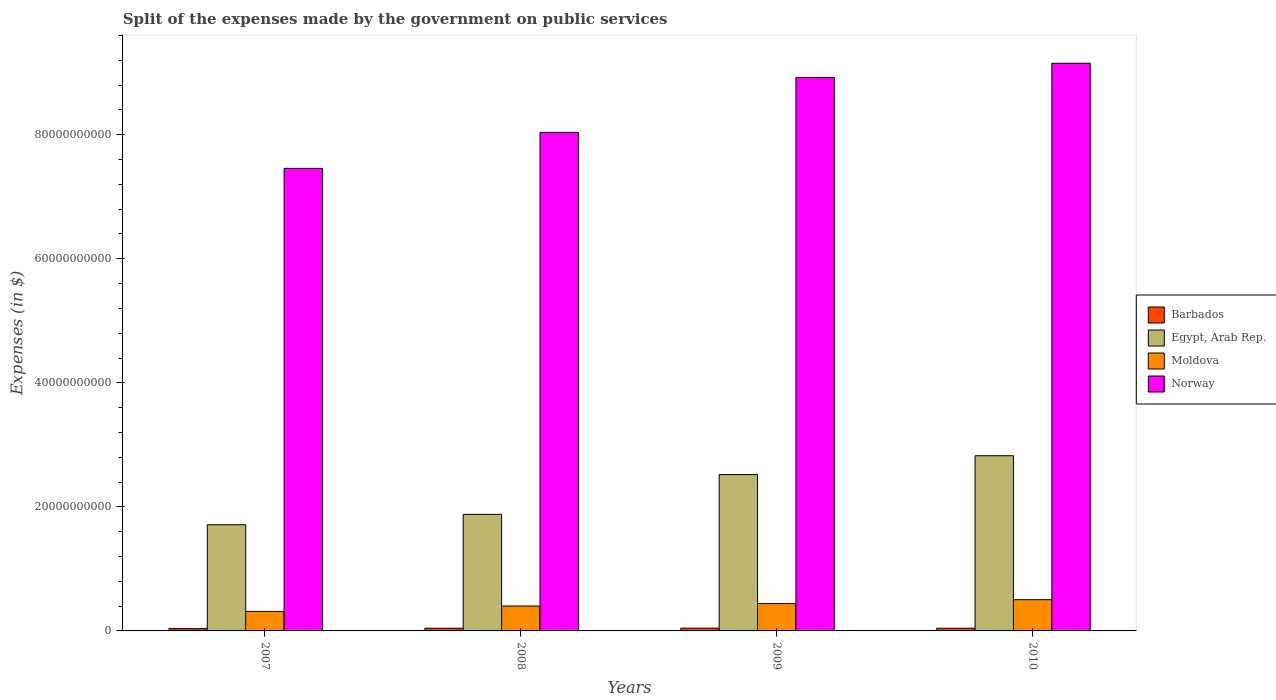How many different coloured bars are there?
Your answer should be compact. 4. Are the number of bars per tick equal to the number of legend labels?
Your response must be concise. Yes. How many bars are there on the 2nd tick from the left?
Ensure brevity in your answer.  4. What is the expenses made by the government on public services in Egypt, Arab Rep. in 2008?
Make the answer very short. 1.88e+1. Across all years, what is the maximum expenses made by the government on public services in Moldova?
Provide a short and direct response. 5.03e+09. Across all years, what is the minimum expenses made by the government on public services in Barbados?
Make the answer very short. 3.67e+08. In which year was the expenses made by the government on public services in Egypt, Arab Rep. maximum?
Your answer should be very brief. 2010. What is the total expenses made by the government on public services in Egypt, Arab Rep. in the graph?
Give a very brief answer. 8.94e+1. What is the difference between the expenses made by the government on public services in Moldova in 2008 and that in 2009?
Your answer should be compact. -3.88e+08. What is the difference between the expenses made by the government on public services in Norway in 2008 and the expenses made by the government on public services in Barbados in 2010?
Offer a very short reply. 7.99e+1. What is the average expenses made by the government on public services in Norway per year?
Make the answer very short. 8.39e+1. In the year 2009, what is the difference between the expenses made by the government on public services in Norway and expenses made by the government on public services in Egypt, Arab Rep.?
Give a very brief answer. 6.40e+1. What is the ratio of the expenses made by the government on public services in Egypt, Arab Rep. in 2007 to that in 2010?
Offer a terse response. 0.61. Is the difference between the expenses made by the government on public services in Norway in 2008 and 2009 greater than the difference between the expenses made by the government on public services in Egypt, Arab Rep. in 2008 and 2009?
Your answer should be very brief. No. What is the difference between the highest and the second highest expenses made by the government on public services in Moldova?
Provide a short and direct response. 6.28e+08. What is the difference between the highest and the lowest expenses made by the government on public services in Egypt, Arab Rep.?
Keep it short and to the point. 1.11e+1. Is it the case that in every year, the sum of the expenses made by the government on public services in Moldova and expenses made by the government on public services in Norway is greater than the sum of expenses made by the government on public services in Egypt, Arab Rep. and expenses made by the government on public services in Barbados?
Offer a very short reply. Yes. What does the 3rd bar from the left in 2008 represents?
Your answer should be very brief. Moldova. What does the 2nd bar from the right in 2008 represents?
Provide a succinct answer. Moldova. How many bars are there?
Keep it short and to the point. 16. Are all the bars in the graph horizontal?
Offer a very short reply. No. How many years are there in the graph?
Ensure brevity in your answer.  4. Are the values on the major ticks of Y-axis written in scientific E-notation?
Give a very brief answer. No. Does the graph contain any zero values?
Your answer should be compact. No. What is the title of the graph?
Your answer should be compact. Split of the expenses made by the government on public services. What is the label or title of the X-axis?
Make the answer very short. Years. What is the label or title of the Y-axis?
Offer a very short reply. Expenses (in $). What is the Expenses (in $) in Barbados in 2007?
Keep it short and to the point. 3.67e+08. What is the Expenses (in $) in Egypt, Arab Rep. in 2007?
Keep it short and to the point. 1.71e+1. What is the Expenses (in $) of Moldova in 2007?
Keep it short and to the point. 3.15e+09. What is the Expenses (in $) of Norway in 2007?
Give a very brief answer. 7.46e+1. What is the Expenses (in $) of Barbados in 2008?
Keep it short and to the point. 4.35e+08. What is the Expenses (in $) of Egypt, Arab Rep. in 2008?
Make the answer very short. 1.88e+1. What is the Expenses (in $) in Moldova in 2008?
Provide a succinct answer. 4.02e+09. What is the Expenses (in $) of Norway in 2008?
Keep it short and to the point. 8.04e+1. What is the Expenses (in $) in Barbados in 2009?
Offer a terse response. 4.44e+08. What is the Expenses (in $) of Egypt, Arab Rep. in 2009?
Provide a succinct answer. 2.52e+1. What is the Expenses (in $) in Moldova in 2009?
Your response must be concise. 4.41e+09. What is the Expenses (in $) of Norway in 2009?
Keep it short and to the point. 8.92e+1. What is the Expenses (in $) of Barbados in 2010?
Provide a short and direct response. 4.35e+08. What is the Expenses (in $) in Egypt, Arab Rep. in 2010?
Your answer should be compact. 2.82e+1. What is the Expenses (in $) of Moldova in 2010?
Make the answer very short. 5.03e+09. What is the Expenses (in $) of Norway in 2010?
Give a very brief answer. 9.15e+1. Across all years, what is the maximum Expenses (in $) of Barbados?
Offer a terse response. 4.44e+08. Across all years, what is the maximum Expenses (in $) of Egypt, Arab Rep.?
Keep it short and to the point. 2.82e+1. Across all years, what is the maximum Expenses (in $) of Moldova?
Give a very brief answer. 5.03e+09. Across all years, what is the maximum Expenses (in $) in Norway?
Offer a very short reply. 9.15e+1. Across all years, what is the minimum Expenses (in $) in Barbados?
Keep it short and to the point. 3.67e+08. Across all years, what is the minimum Expenses (in $) of Egypt, Arab Rep.?
Ensure brevity in your answer.  1.71e+1. Across all years, what is the minimum Expenses (in $) of Moldova?
Your response must be concise. 3.15e+09. Across all years, what is the minimum Expenses (in $) in Norway?
Your answer should be compact. 7.46e+1. What is the total Expenses (in $) of Barbados in the graph?
Provide a succinct answer. 1.68e+09. What is the total Expenses (in $) of Egypt, Arab Rep. in the graph?
Keep it short and to the point. 8.94e+1. What is the total Expenses (in $) of Moldova in the graph?
Provide a succinct answer. 1.66e+1. What is the total Expenses (in $) in Norway in the graph?
Your response must be concise. 3.36e+11. What is the difference between the Expenses (in $) in Barbados in 2007 and that in 2008?
Your response must be concise. -6.75e+07. What is the difference between the Expenses (in $) in Egypt, Arab Rep. in 2007 and that in 2008?
Make the answer very short. -1.67e+09. What is the difference between the Expenses (in $) of Moldova in 2007 and that in 2008?
Make the answer very short. -8.67e+08. What is the difference between the Expenses (in $) in Norway in 2007 and that in 2008?
Your answer should be very brief. -5.81e+09. What is the difference between the Expenses (in $) of Barbados in 2007 and that in 2009?
Give a very brief answer. -7.74e+07. What is the difference between the Expenses (in $) in Egypt, Arab Rep. in 2007 and that in 2009?
Keep it short and to the point. -8.08e+09. What is the difference between the Expenses (in $) of Moldova in 2007 and that in 2009?
Give a very brief answer. -1.26e+09. What is the difference between the Expenses (in $) in Norway in 2007 and that in 2009?
Give a very brief answer. -1.47e+1. What is the difference between the Expenses (in $) of Barbados in 2007 and that in 2010?
Keep it short and to the point. -6.83e+07. What is the difference between the Expenses (in $) in Egypt, Arab Rep. in 2007 and that in 2010?
Your answer should be very brief. -1.11e+1. What is the difference between the Expenses (in $) in Moldova in 2007 and that in 2010?
Your answer should be compact. -1.88e+09. What is the difference between the Expenses (in $) of Norway in 2007 and that in 2010?
Give a very brief answer. -1.70e+1. What is the difference between the Expenses (in $) of Barbados in 2008 and that in 2009?
Provide a short and direct response. -9.82e+06. What is the difference between the Expenses (in $) of Egypt, Arab Rep. in 2008 and that in 2009?
Keep it short and to the point. -6.41e+09. What is the difference between the Expenses (in $) in Moldova in 2008 and that in 2009?
Give a very brief answer. -3.88e+08. What is the difference between the Expenses (in $) in Norway in 2008 and that in 2009?
Offer a very short reply. -8.85e+09. What is the difference between the Expenses (in $) in Barbados in 2008 and that in 2010?
Your answer should be very brief. -7.51e+05. What is the difference between the Expenses (in $) in Egypt, Arab Rep. in 2008 and that in 2010?
Your answer should be compact. -9.46e+09. What is the difference between the Expenses (in $) of Moldova in 2008 and that in 2010?
Provide a short and direct response. -1.02e+09. What is the difference between the Expenses (in $) in Norway in 2008 and that in 2010?
Keep it short and to the point. -1.11e+1. What is the difference between the Expenses (in $) in Barbados in 2009 and that in 2010?
Provide a short and direct response. 9.07e+06. What is the difference between the Expenses (in $) of Egypt, Arab Rep. in 2009 and that in 2010?
Your answer should be very brief. -3.04e+09. What is the difference between the Expenses (in $) in Moldova in 2009 and that in 2010?
Make the answer very short. -6.28e+08. What is the difference between the Expenses (in $) in Norway in 2009 and that in 2010?
Make the answer very short. -2.29e+09. What is the difference between the Expenses (in $) in Barbados in 2007 and the Expenses (in $) in Egypt, Arab Rep. in 2008?
Provide a short and direct response. -1.84e+1. What is the difference between the Expenses (in $) in Barbados in 2007 and the Expenses (in $) in Moldova in 2008?
Keep it short and to the point. -3.65e+09. What is the difference between the Expenses (in $) in Barbados in 2007 and the Expenses (in $) in Norway in 2008?
Your answer should be very brief. -8.00e+1. What is the difference between the Expenses (in $) in Egypt, Arab Rep. in 2007 and the Expenses (in $) in Moldova in 2008?
Ensure brevity in your answer.  1.31e+1. What is the difference between the Expenses (in $) in Egypt, Arab Rep. in 2007 and the Expenses (in $) in Norway in 2008?
Give a very brief answer. -6.33e+1. What is the difference between the Expenses (in $) of Moldova in 2007 and the Expenses (in $) of Norway in 2008?
Provide a succinct answer. -7.72e+1. What is the difference between the Expenses (in $) of Barbados in 2007 and the Expenses (in $) of Egypt, Arab Rep. in 2009?
Provide a succinct answer. -2.48e+1. What is the difference between the Expenses (in $) in Barbados in 2007 and the Expenses (in $) in Moldova in 2009?
Provide a short and direct response. -4.04e+09. What is the difference between the Expenses (in $) in Barbados in 2007 and the Expenses (in $) in Norway in 2009?
Offer a very short reply. -8.89e+1. What is the difference between the Expenses (in $) in Egypt, Arab Rep. in 2007 and the Expenses (in $) in Moldova in 2009?
Your answer should be very brief. 1.27e+1. What is the difference between the Expenses (in $) of Egypt, Arab Rep. in 2007 and the Expenses (in $) of Norway in 2009?
Provide a short and direct response. -7.21e+1. What is the difference between the Expenses (in $) in Moldova in 2007 and the Expenses (in $) in Norway in 2009?
Provide a succinct answer. -8.61e+1. What is the difference between the Expenses (in $) of Barbados in 2007 and the Expenses (in $) of Egypt, Arab Rep. in 2010?
Offer a terse response. -2.79e+1. What is the difference between the Expenses (in $) in Barbados in 2007 and the Expenses (in $) in Moldova in 2010?
Your response must be concise. -4.67e+09. What is the difference between the Expenses (in $) of Barbados in 2007 and the Expenses (in $) of Norway in 2010?
Provide a short and direct response. -9.12e+1. What is the difference between the Expenses (in $) of Egypt, Arab Rep. in 2007 and the Expenses (in $) of Moldova in 2010?
Your response must be concise. 1.21e+1. What is the difference between the Expenses (in $) of Egypt, Arab Rep. in 2007 and the Expenses (in $) of Norway in 2010?
Your answer should be very brief. -7.44e+1. What is the difference between the Expenses (in $) in Moldova in 2007 and the Expenses (in $) in Norway in 2010?
Make the answer very short. -8.84e+1. What is the difference between the Expenses (in $) of Barbados in 2008 and the Expenses (in $) of Egypt, Arab Rep. in 2009?
Offer a terse response. -2.48e+1. What is the difference between the Expenses (in $) of Barbados in 2008 and the Expenses (in $) of Moldova in 2009?
Your response must be concise. -3.97e+09. What is the difference between the Expenses (in $) of Barbados in 2008 and the Expenses (in $) of Norway in 2009?
Ensure brevity in your answer.  -8.88e+1. What is the difference between the Expenses (in $) in Egypt, Arab Rep. in 2008 and the Expenses (in $) in Moldova in 2009?
Offer a terse response. 1.44e+1. What is the difference between the Expenses (in $) in Egypt, Arab Rep. in 2008 and the Expenses (in $) in Norway in 2009?
Keep it short and to the point. -7.04e+1. What is the difference between the Expenses (in $) in Moldova in 2008 and the Expenses (in $) in Norway in 2009?
Make the answer very short. -8.52e+1. What is the difference between the Expenses (in $) of Barbados in 2008 and the Expenses (in $) of Egypt, Arab Rep. in 2010?
Offer a very short reply. -2.78e+1. What is the difference between the Expenses (in $) of Barbados in 2008 and the Expenses (in $) of Moldova in 2010?
Provide a short and direct response. -4.60e+09. What is the difference between the Expenses (in $) in Barbados in 2008 and the Expenses (in $) in Norway in 2010?
Provide a succinct answer. -9.11e+1. What is the difference between the Expenses (in $) of Egypt, Arab Rep. in 2008 and the Expenses (in $) of Moldova in 2010?
Keep it short and to the point. 1.38e+1. What is the difference between the Expenses (in $) in Egypt, Arab Rep. in 2008 and the Expenses (in $) in Norway in 2010?
Provide a succinct answer. -7.27e+1. What is the difference between the Expenses (in $) in Moldova in 2008 and the Expenses (in $) in Norway in 2010?
Your response must be concise. -8.75e+1. What is the difference between the Expenses (in $) of Barbados in 2009 and the Expenses (in $) of Egypt, Arab Rep. in 2010?
Your answer should be very brief. -2.78e+1. What is the difference between the Expenses (in $) of Barbados in 2009 and the Expenses (in $) of Moldova in 2010?
Offer a terse response. -4.59e+09. What is the difference between the Expenses (in $) in Barbados in 2009 and the Expenses (in $) in Norway in 2010?
Ensure brevity in your answer.  -9.11e+1. What is the difference between the Expenses (in $) in Egypt, Arab Rep. in 2009 and the Expenses (in $) in Moldova in 2010?
Offer a terse response. 2.02e+1. What is the difference between the Expenses (in $) in Egypt, Arab Rep. in 2009 and the Expenses (in $) in Norway in 2010?
Ensure brevity in your answer.  -6.63e+1. What is the difference between the Expenses (in $) of Moldova in 2009 and the Expenses (in $) of Norway in 2010?
Your response must be concise. -8.71e+1. What is the average Expenses (in $) of Barbados per year?
Provide a succinct answer. 4.20e+08. What is the average Expenses (in $) in Egypt, Arab Rep. per year?
Your response must be concise. 2.23e+1. What is the average Expenses (in $) of Moldova per year?
Your answer should be very brief. 4.15e+09. What is the average Expenses (in $) in Norway per year?
Provide a short and direct response. 8.39e+1. In the year 2007, what is the difference between the Expenses (in $) of Barbados and Expenses (in $) of Egypt, Arab Rep.?
Give a very brief answer. -1.68e+1. In the year 2007, what is the difference between the Expenses (in $) in Barbados and Expenses (in $) in Moldova?
Offer a terse response. -2.78e+09. In the year 2007, what is the difference between the Expenses (in $) in Barbados and Expenses (in $) in Norway?
Provide a short and direct response. -7.42e+1. In the year 2007, what is the difference between the Expenses (in $) of Egypt, Arab Rep. and Expenses (in $) of Moldova?
Your answer should be very brief. 1.40e+1. In the year 2007, what is the difference between the Expenses (in $) of Egypt, Arab Rep. and Expenses (in $) of Norway?
Ensure brevity in your answer.  -5.74e+1. In the year 2007, what is the difference between the Expenses (in $) in Moldova and Expenses (in $) in Norway?
Keep it short and to the point. -7.14e+1. In the year 2008, what is the difference between the Expenses (in $) in Barbados and Expenses (in $) in Egypt, Arab Rep.?
Your response must be concise. -1.84e+1. In the year 2008, what is the difference between the Expenses (in $) of Barbados and Expenses (in $) of Moldova?
Make the answer very short. -3.58e+09. In the year 2008, what is the difference between the Expenses (in $) of Barbados and Expenses (in $) of Norway?
Make the answer very short. -7.99e+1. In the year 2008, what is the difference between the Expenses (in $) of Egypt, Arab Rep. and Expenses (in $) of Moldova?
Your answer should be very brief. 1.48e+1. In the year 2008, what is the difference between the Expenses (in $) in Egypt, Arab Rep. and Expenses (in $) in Norway?
Your answer should be very brief. -6.16e+1. In the year 2008, what is the difference between the Expenses (in $) of Moldova and Expenses (in $) of Norway?
Ensure brevity in your answer.  -7.64e+1. In the year 2009, what is the difference between the Expenses (in $) in Barbados and Expenses (in $) in Egypt, Arab Rep.?
Provide a short and direct response. -2.48e+1. In the year 2009, what is the difference between the Expenses (in $) of Barbados and Expenses (in $) of Moldova?
Provide a short and direct response. -3.96e+09. In the year 2009, what is the difference between the Expenses (in $) in Barbados and Expenses (in $) in Norway?
Provide a succinct answer. -8.88e+1. In the year 2009, what is the difference between the Expenses (in $) in Egypt, Arab Rep. and Expenses (in $) in Moldova?
Offer a terse response. 2.08e+1. In the year 2009, what is the difference between the Expenses (in $) in Egypt, Arab Rep. and Expenses (in $) in Norway?
Keep it short and to the point. -6.40e+1. In the year 2009, what is the difference between the Expenses (in $) in Moldova and Expenses (in $) in Norway?
Your response must be concise. -8.48e+1. In the year 2010, what is the difference between the Expenses (in $) in Barbados and Expenses (in $) in Egypt, Arab Rep.?
Your response must be concise. -2.78e+1. In the year 2010, what is the difference between the Expenses (in $) in Barbados and Expenses (in $) in Moldova?
Provide a short and direct response. -4.60e+09. In the year 2010, what is the difference between the Expenses (in $) in Barbados and Expenses (in $) in Norway?
Provide a succinct answer. -9.11e+1. In the year 2010, what is the difference between the Expenses (in $) of Egypt, Arab Rep. and Expenses (in $) of Moldova?
Provide a succinct answer. 2.32e+1. In the year 2010, what is the difference between the Expenses (in $) in Egypt, Arab Rep. and Expenses (in $) in Norway?
Give a very brief answer. -6.33e+1. In the year 2010, what is the difference between the Expenses (in $) in Moldova and Expenses (in $) in Norway?
Ensure brevity in your answer.  -8.65e+1. What is the ratio of the Expenses (in $) of Barbados in 2007 to that in 2008?
Offer a very short reply. 0.84. What is the ratio of the Expenses (in $) in Egypt, Arab Rep. in 2007 to that in 2008?
Your answer should be very brief. 0.91. What is the ratio of the Expenses (in $) in Moldova in 2007 to that in 2008?
Your answer should be very brief. 0.78. What is the ratio of the Expenses (in $) of Norway in 2007 to that in 2008?
Give a very brief answer. 0.93. What is the ratio of the Expenses (in $) of Barbados in 2007 to that in 2009?
Provide a succinct answer. 0.83. What is the ratio of the Expenses (in $) of Egypt, Arab Rep. in 2007 to that in 2009?
Your response must be concise. 0.68. What is the ratio of the Expenses (in $) in Moldova in 2007 to that in 2009?
Give a very brief answer. 0.71. What is the ratio of the Expenses (in $) in Norway in 2007 to that in 2009?
Your answer should be compact. 0.84. What is the ratio of the Expenses (in $) in Barbados in 2007 to that in 2010?
Offer a terse response. 0.84. What is the ratio of the Expenses (in $) of Egypt, Arab Rep. in 2007 to that in 2010?
Ensure brevity in your answer.  0.61. What is the ratio of the Expenses (in $) of Moldova in 2007 to that in 2010?
Provide a succinct answer. 0.63. What is the ratio of the Expenses (in $) of Norway in 2007 to that in 2010?
Your answer should be very brief. 0.81. What is the ratio of the Expenses (in $) in Barbados in 2008 to that in 2009?
Your response must be concise. 0.98. What is the ratio of the Expenses (in $) in Egypt, Arab Rep. in 2008 to that in 2009?
Ensure brevity in your answer.  0.75. What is the ratio of the Expenses (in $) of Moldova in 2008 to that in 2009?
Give a very brief answer. 0.91. What is the ratio of the Expenses (in $) in Norway in 2008 to that in 2009?
Offer a very short reply. 0.9. What is the ratio of the Expenses (in $) in Egypt, Arab Rep. in 2008 to that in 2010?
Keep it short and to the point. 0.67. What is the ratio of the Expenses (in $) of Moldova in 2008 to that in 2010?
Keep it short and to the point. 0.8. What is the ratio of the Expenses (in $) of Norway in 2008 to that in 2010?
Offer a terse response. 0.88. What is the ratio of the Expenses (in $) of Barbados in 2009 to that in 2010?
Provide a short and direct response. 1.02. What is the ratio of the Expenses (in $) of Egypt, Arab Rep. in 2009 to that in 2010?
Provide a succinct answer. 0.89. What is the ratio of the Expenses (in $) in Moldova in 2009 to that in 2010?
Your answer should be very brief. 0.88. What is the difference between the highest and the second highest Expenses (in $) of Barbados?
Provide a succinct answer. 9.07e+06. What is the difference between the highest and the second highest Expenses (in $) of Egypt, Arab Rep.?
Make the answer very short. 3.04e+09. What is the difference between the highest and the second highest Expenses (in $) in Moldova?
Your answer should be very brief. 6.28e+08. What is the difference between the highest and the second highest Expenses (in $) of Norway?
Your response must be concise. 2.29e+09. What is the difference between the highest and the lowest Expenses (in $) of Barbados?
Your response must be concise. 7.74e+07. What is the difference between the highest and the lowest Expenses (in $) in Egypt, Arab Rep.?
Offer a terse response. 1.11e+1. What is the difference between the highest and the lowest Expenses (in $) of Moldova?
Make the answer very short. 1.88e+09. What is the difference between the highest and the lowest Expenses (in $) of Norway?
Your response must be concise. 1.70e+1. 